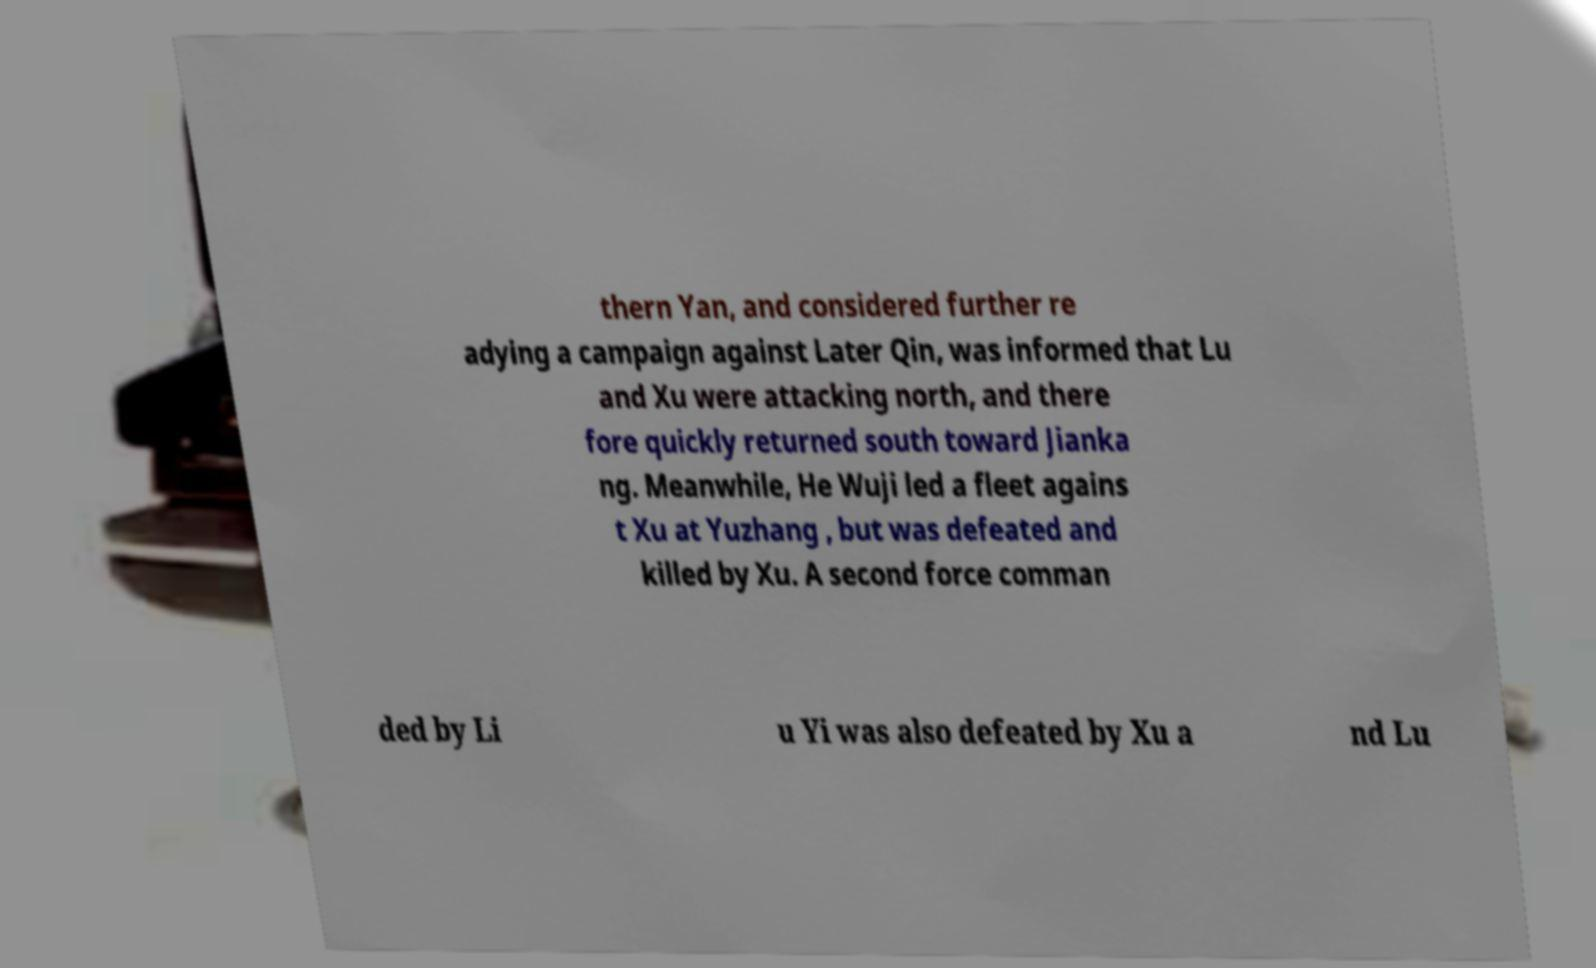There's text embedded in this image that I need extracted. Can you transcribe it verbatim? thern Yan, and considered further re adying a campaign against Later Qin, was informed that Lu and Xu were attacking north, and there fore quickly returned south toward Jianka ng. Meanwhile, He Wuji led a fleet agains t Xu at Yuzhang , but was defeated and killed by Xu. A second force comman ded by Li u Yi was also defeated by Xu a nd Lu 